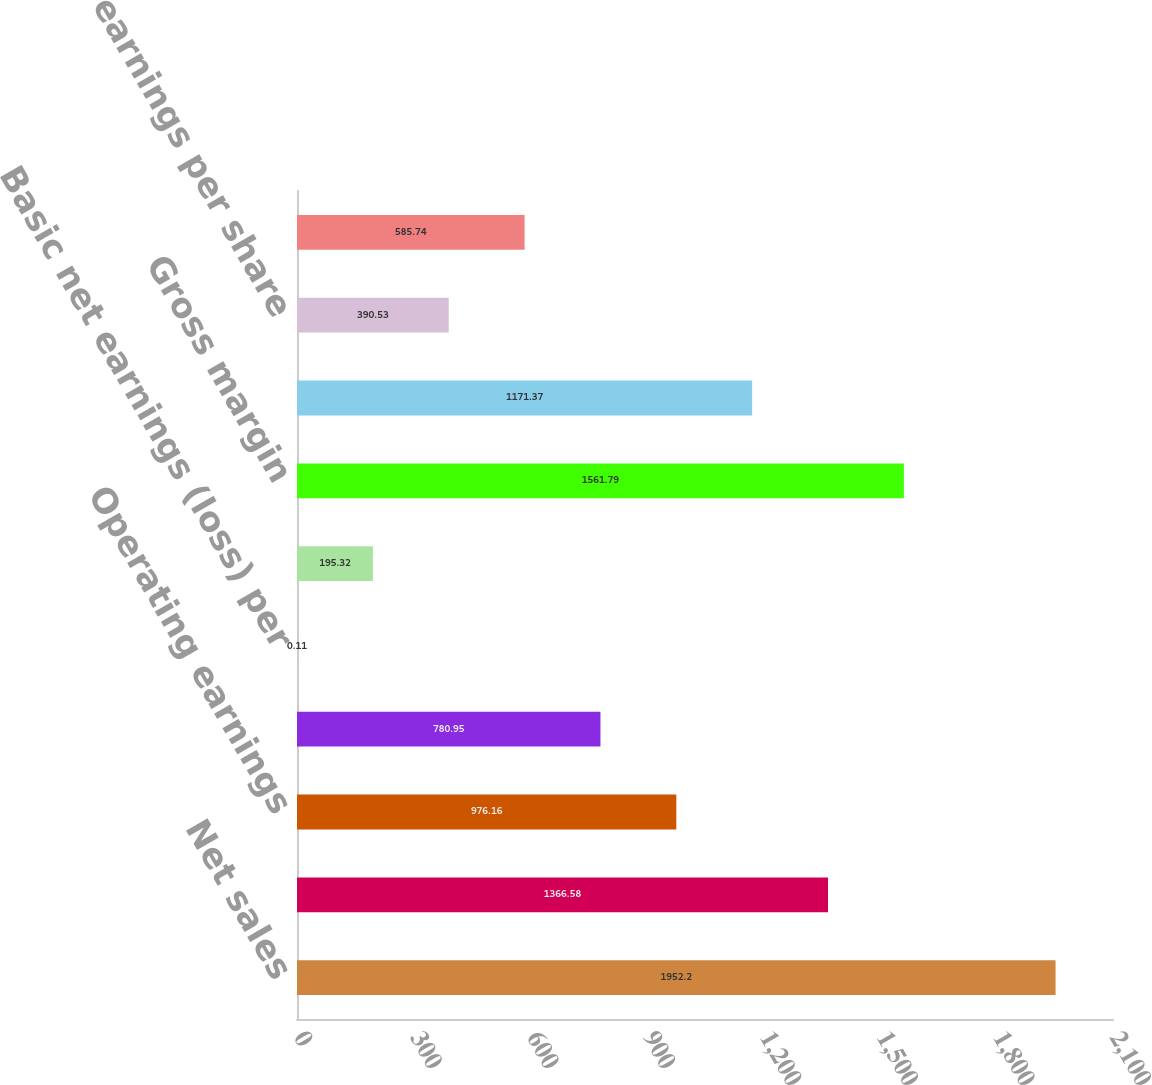Convert chart to OTSL. <chart><loc_0><loc_0><loc_500><loc_500><bar_chart><fcel>Net sales<fcel>Gross margin (a)<fcel>Operating earnings<fcel>Net earnings (loss)<fcel>Basic net earnings (loss) per<fcel>Diluted net earnings (loss)<fcel>Gross margin<fcel>Net earnings attributable to<fcel>Basic net earnings per share<fcel>Diluted net earnings per share<nl><fcel>1952.2<fcel>1366.58<fcel>976.16<fcel>780.95<fcel>0.11<fcel>195.32<fcel>1561.79<fcel>1171.37<fcel>390.53<fcel>585.74<nl></chart> 